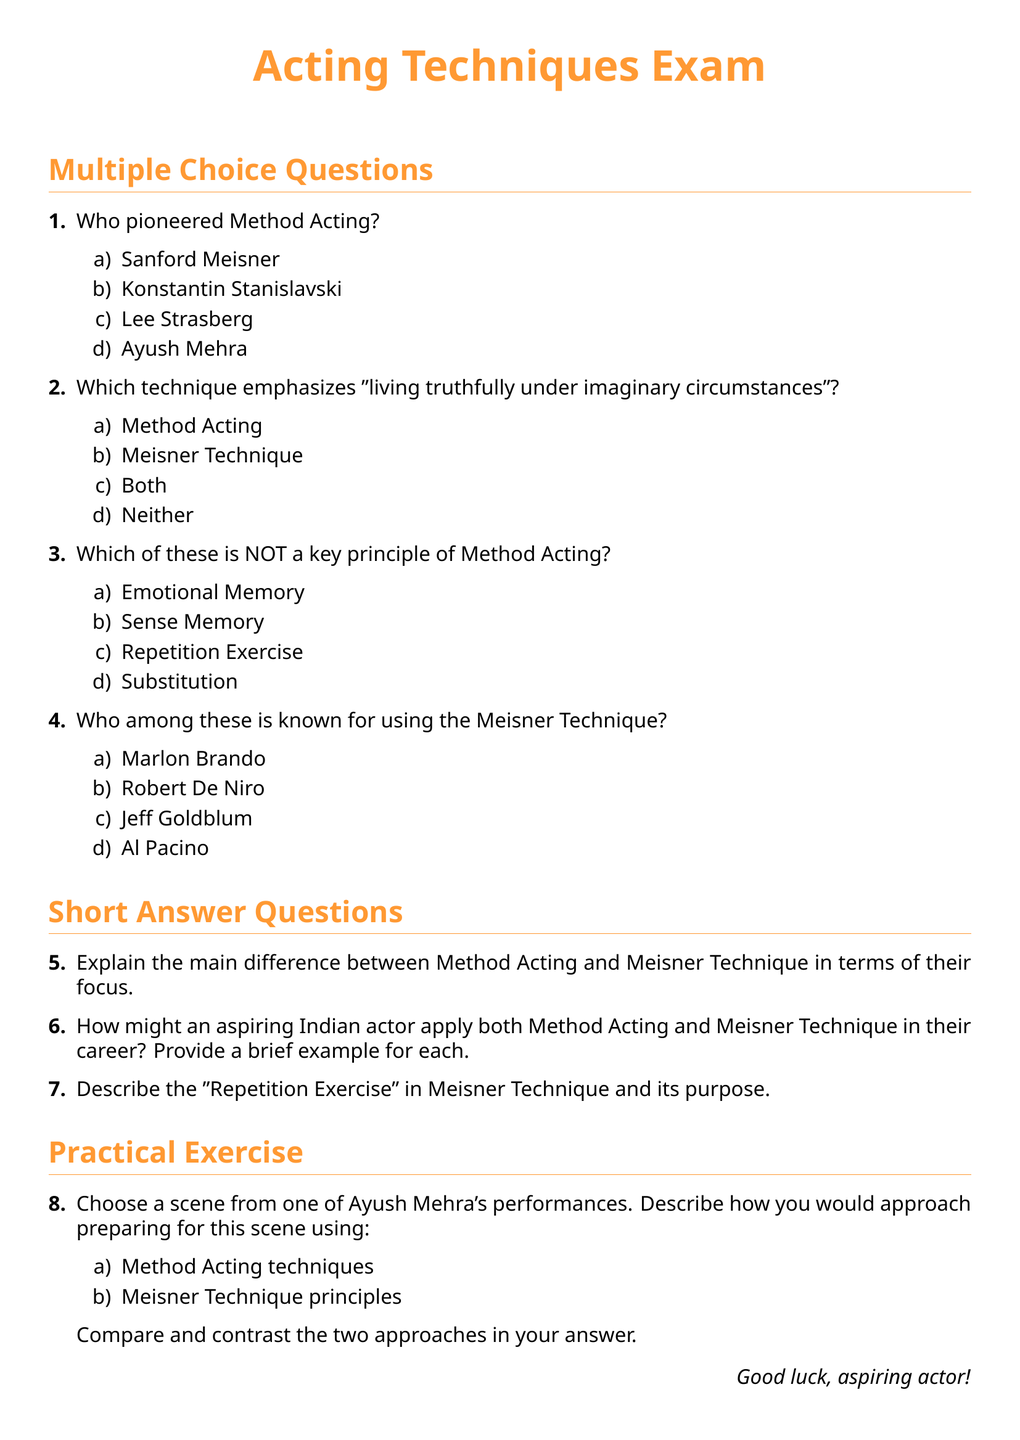What is the title of the exam? The title of the exam is presented at the top of the document in a larger font.
Answer: Acting Techniques Exam Who pioneered Method Acting? This is a multiple-choice question in the exam that asks for the person associated with Method Acting.
Answer: Lee Strasberg Which technique emphasizes "living truthfully under imaginary circumstances"? This question is included in the multiple-choice section and identifies a key aspect of an acting technique.
Answer: Method Acting What is a key principle of Method Acting? The exam provides a list of principles in a question, and we need to identify one.
Answer: Emotional Memory How many short answer questions are there? The document outlines the structure of the exam and indicates the number of short answer questions.
Answer: Three What practical exercise do actors have to perform? This question refers to the practical exercise section focused on scene preparation using different techniques.
Answer: Choose a scene from Ayush Mehra's performances Describe the main focus of Method Acting This question relates to distinguishing features of Method Acting as presented in the exam.
Answer: Emotional involvement What is the purpose of the Repetition Exercise? This question seeks to explore the objective behind a specific component of the Meisner Technique mentioned in the short answer section.
Answer: To develop listening and spontaneity Who is a known user of the Meisner Technique? This would refer to the answer options provided in the multiple-choice section.
Answer: Jeff Goldblum What color is used for headings in the document? The document outlines specific colors for different sections, influencing visual clarity.
Answer: maincolor 